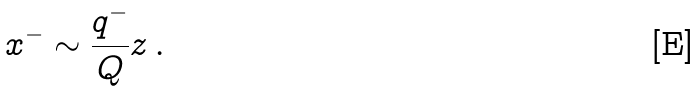Convert formula to latex. <formula><loc_0><loc_0><loc_500><loc_500>x ^ { - } \sim \frac { q ^ { - } } { Q } z \, .</formula> 